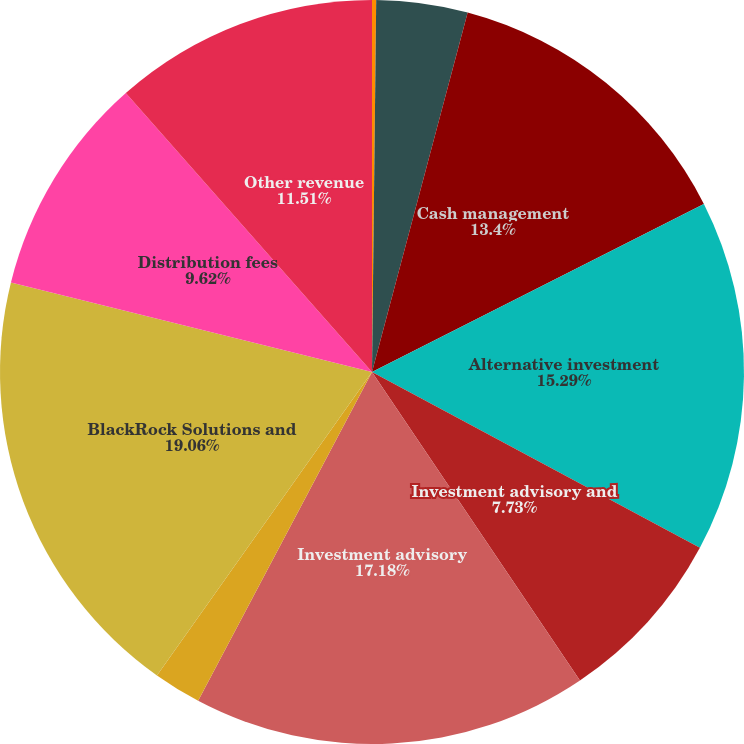Convert chart. <chart><loc_0><loc_0><loc_500><loc_500><pie_chart><fcel>Fixed income<fcel>Equity and balanced<fcel>Cash management<fcel>Alternative investment<fcel>Investment advisory and<fcel>Investment advisory<fcel>Total investment advisory and<fcel>BlackRock Solutions and<fcel>Distribution fees<fcel>Other revenue<nl><fcel>0.18%<fcel>3.96%<fcel>13.4%<fcel>15.29%<fcel>7.73%<fcel>17.18%<fcel>2.07%<fcel>19.06%<fcel>9.62%<fcel>11.51%<nl></chart> 